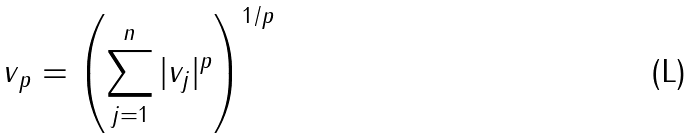Convert formula to latex. <formula><loc_0><loc_0><loc_500><loc_500>\| v \| _ { p } = \left ( \sum _ { j = 1 } ^ { n } | v _ { j } | ^ { p } \right ) ^ { 1 / p }</formula> 